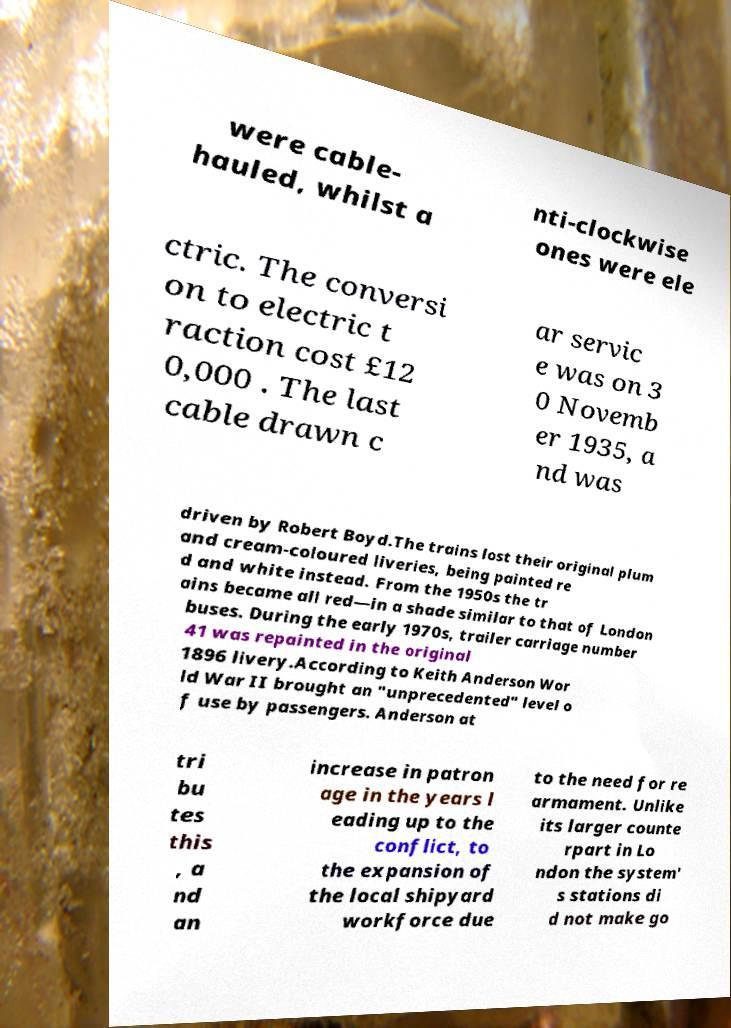Can you read and provide the text displayed in the image?This photo seems to have some interesting text. Can you extract and type it out for me? were cable- hauled, whilst a nti-clockwise ones were ele ctric. The conversi on to electric t raction cost £12 0,000 . The last cable drawn c ar servic e was on 3 0 Novemb er 1935, a nd was driven by Robert Boyd.The trains lost their original plum and cream-coloured liveries, being painted re d and white instead. From the 1950s the tr ains became all red—in a shade similar to that of London buses. During the early 1970s, trailer carriage number 41 was repainted in the original 1896 livery.According to Keith Anderson Wor ld War II brought an "unprecedented" level o f use by passengers. Anderson at tri bu tes this , a nd an increase in patron age in the years l eading up to the conflict, to the expansion of the local shipyard workforce due to the need for re armament. Unlike its larger counte rpart in Lo ndon the system' s stations di d not make go 